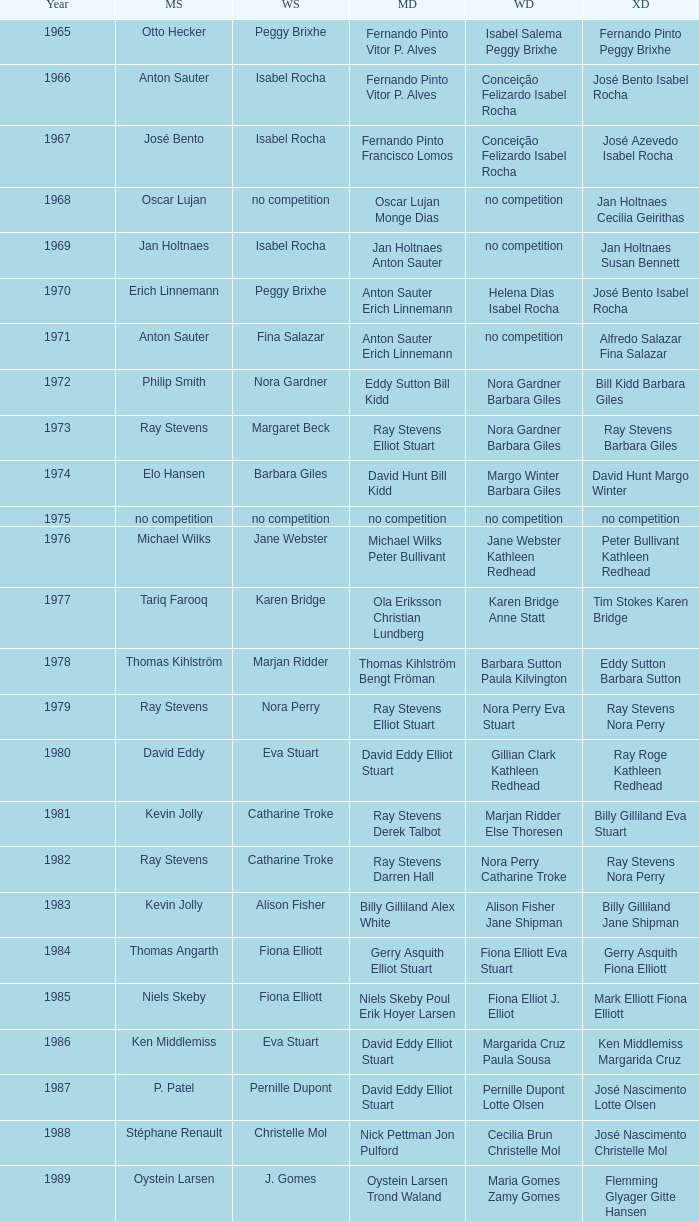Which women's doubles happened after 1987 and a women's single of astrid van der knaap? Elena Denisova Marina Yakusheva. 